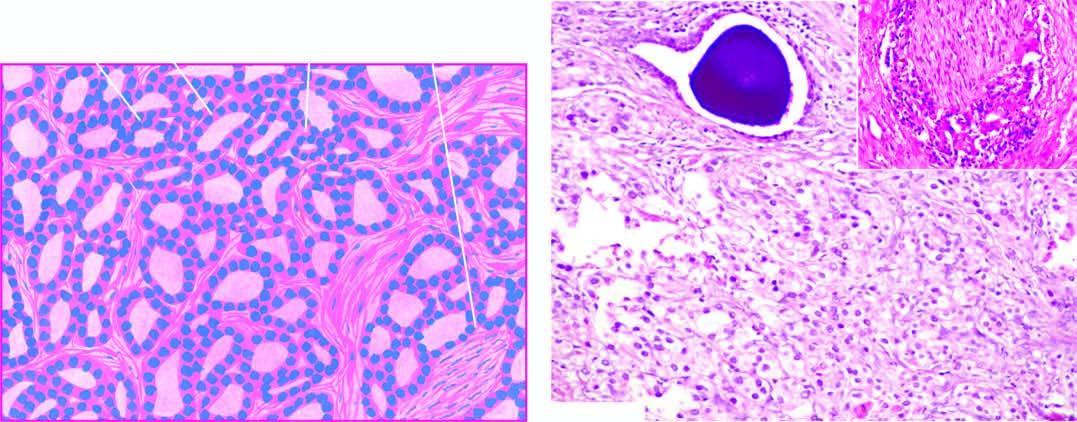does moebic liver abscess show perineural invasion by prostatic adenocarcinoma?
Answer the question using a single word or phrase. No 